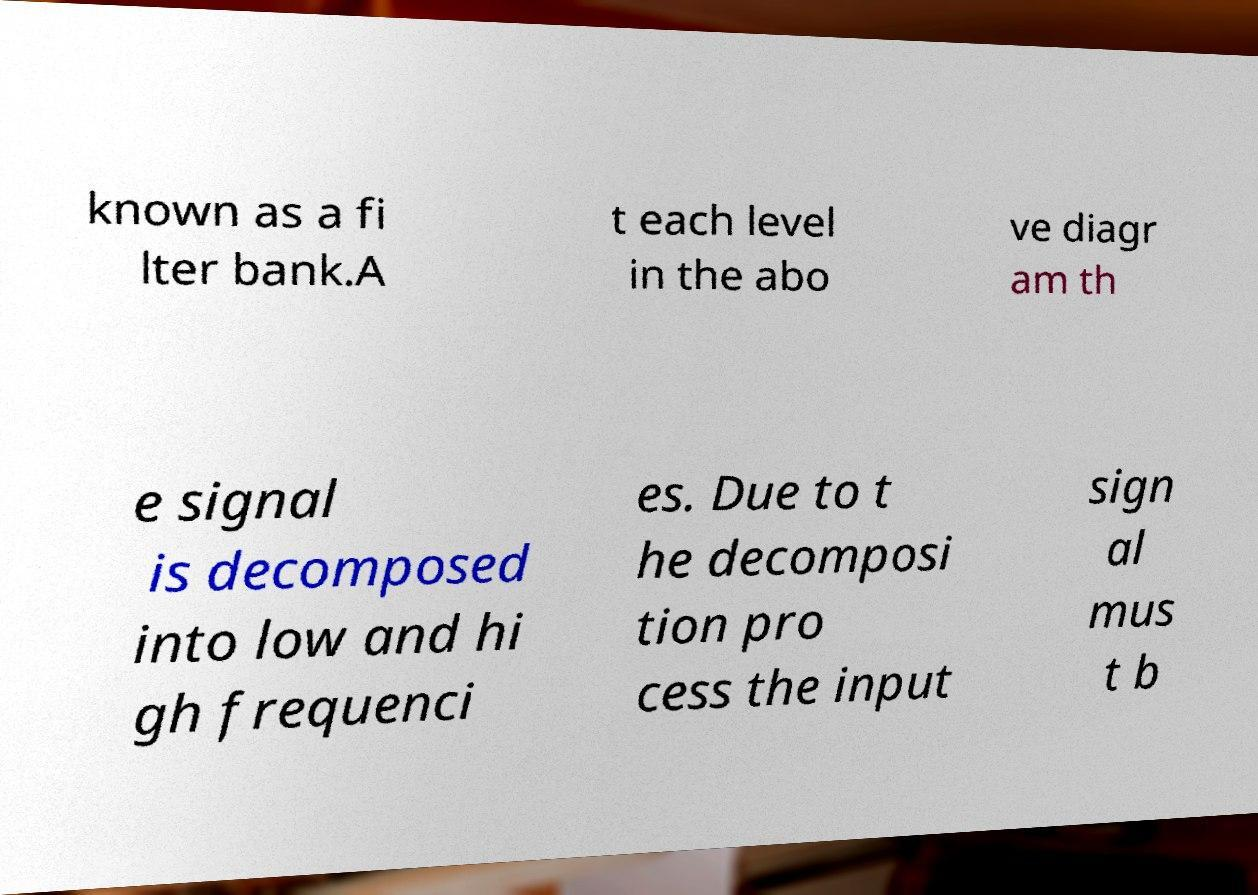I need the written content from this picture converted into text. Can you do that? known as a fi lter bank.A t each level in the abo ve diagr am th e signal is decomposed into low and hi gh frequenci es. Due to t he decomposi tion pro cess the input sign al mus t b 